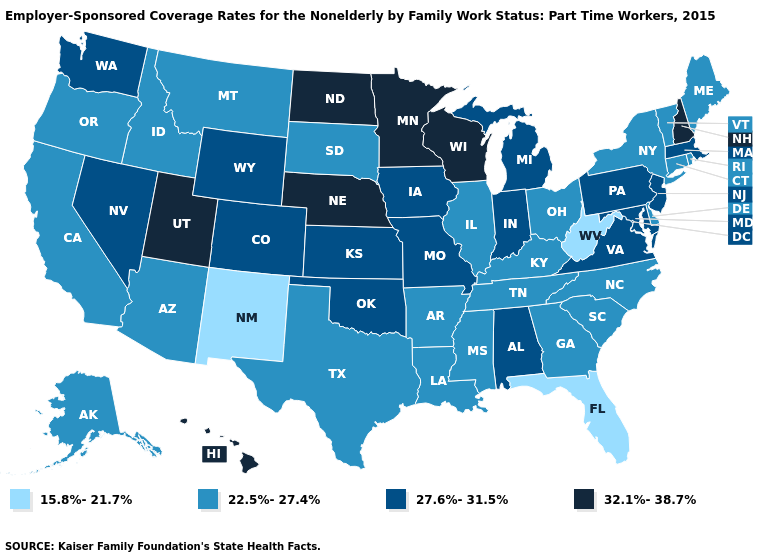Name the states that have a value in the range 15.8%-21.7%?
Answer briefly. Florida, New Mexico, West Virginia. Does the map have missing data?
Give a very brief answer. No. What is the highest value in states that border Maryland?
Give a very brief answer. 27.6%-31.5%. Does South Dakota have the lowest value in the MidWest?
Quick response, please. Yes. What is the highest value in states that border North Dakota?
Quick response, please. 32.1%-38.7%. Among the states that border Georgia , which have the highest value?
Answer briefly. Alabama. Name the states that have a value in the range 22.5%-27.4%?
Quick response, please. Alaska, Arizona, Arkansas, California, Connecticut, Delaware, Georgia, Idaho, Illinois, Kentucky, Louisiana, Maine, Mississippi, Montana, New York, North Carolina, Ohio, Oregon, Rhode Island, South Carolina, South Dakota, Tennessee, Texas, Vermont. Among the states that border Nevada , does Utah have the highest value?
Keep it brief. Yes. Name the states that have a value in the range 27.6%-31.5%?
Concise answer only. Alabama, Colorado, Indiana, Iowa, Kansas, Maryland, Massachusetts, Michigan, Missouri, Nevada, New Jersey, Oklahoma, Pennsylvania, Virginia, Washington, Wyoming. Does the first symbol in the legend represent the smallest category?
Answer briefly. Yes. Does the first symbol in the legend represent the smallest category?
Be succinct. Yes. Does Delaware have a higher value than New Mexico?
Give a very brief answer. Yes. Name the states that have a value in the range 15.8%-21.7%?
Give a very brief answer. Florida, New Mexico, West Virginia. Does the map have missing data?
Answer briefly. No. Among the states that border Michigan , does Wisconsin have the highest value?
Answer briefly. Yes. 